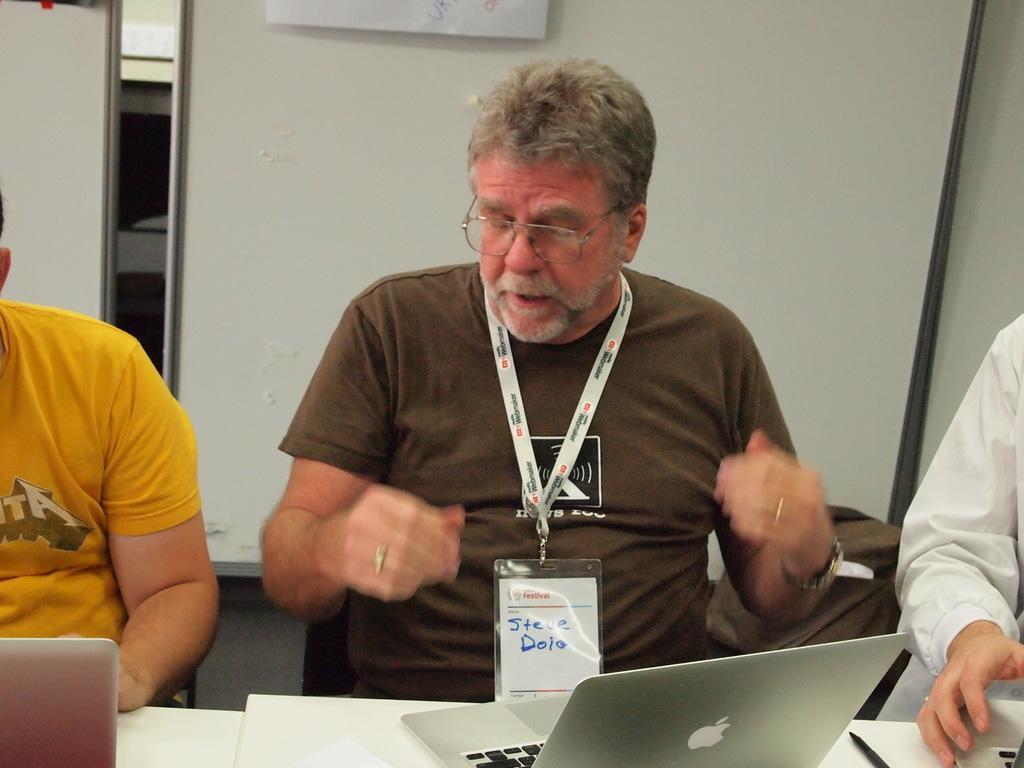Can you describe this image briefly? In this image, we can persons wearing clothes. There are laptops on the table. In the background, we can see a board. 